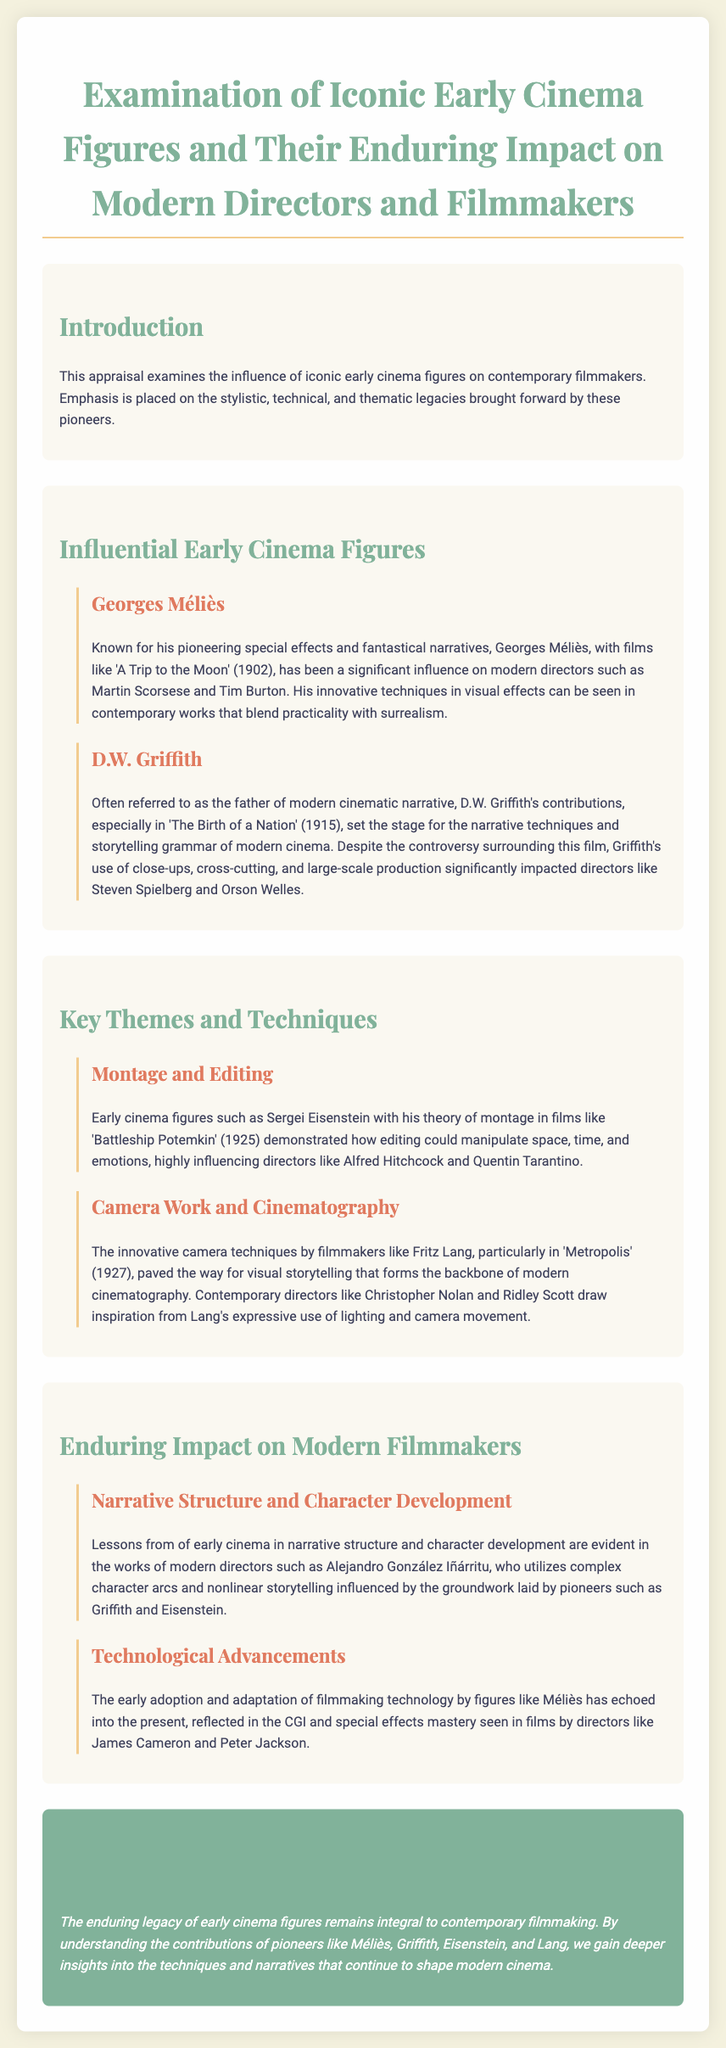What film is Georges Méliès known for? The document mentions 'A Trip to the Moon' (1902) as the film Georges Méliès is known for.
Answer: A Trip to the Moon (1902) Who is referred to as the father of modern cinematic narrative? According to the document, D.W. Griffith is referred to as the father of modern cinematic narrative.
Answer: D.W. Griffith Which editing theory did Sergei Eisenstein pioneer? The document states that Sergei Eisenstein pioneered the theory of montage.
Answer: Montage What is a significant contribution of D.W. Griffith? D.W. Griffith's use of close-ups, cross-cutting, and large-scale production is highlighted as a significant contribution.
Answer: Close-ups, cross-cutting, and large-scale production Which director was influenced by Fritz Lang's cinematography? The document notes that Christopher Nolan was influenced by Fritz Lang's expressive use of lighting and camera movement.
Answer: Christopher Nolan In which year was 'Battleship Potemkin' released? The document states that 'Battleship Potemkin' was released in 1925.
Answer: 1925 Which modern director utilizes nonlinear storytelling? Alejandro González Iñárritu is mentioned as utilizing nonlinear storytelling, influenced by early cinema.
Answer: Alejandro González Iñárritu What is emphasized in the introduction of the document? The introduction emphasizes the influence of iconic early cinema figures on contemporary filmmakers.
Answer: Influence of iconic early cinema figures How did early figures like Méliès impact contemporary film technology? The document suggests that Méliès’s early adoption and adaptation of filmmaking technology echoed into the present.
Answer: Filmmaking technology 